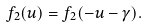<formula> <loc_0><loc_0><loc_500><loc_500>f _ { 2 } ( u ) = f _ { 2 } ( - u - \gamma ) .</formula> 